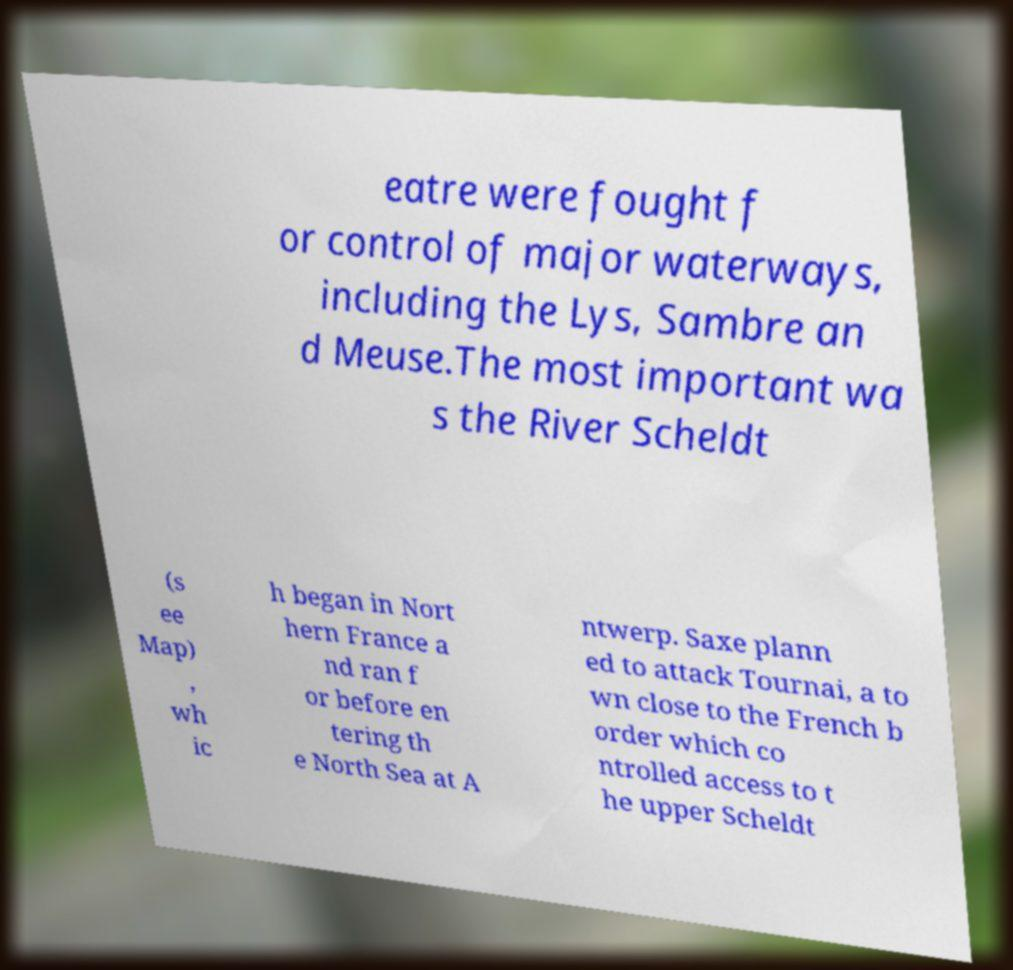Please read and relay the text visible in this image. What does it say? eatre were fought f or control of major waterways, including the Lys, Sambre an d Meuse.The most important wa s the River Scheldt (s ee Map) , wh ic h began in Nort hern France a nd ran f or before en tering th e North Sea at A ntwerp. Saxe plann ed to attack Tournai, a to wn close to the French b order which co ntrolled access to t he upper Scheldt 